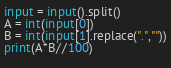Convert code to text. <code><loc_0><loc_0><loc_500><loc_500><_Python_>input = input().split()
A = int(input[0])
B = int(input[1].replace(".",""))
print(A*B//100)       
  </code> 